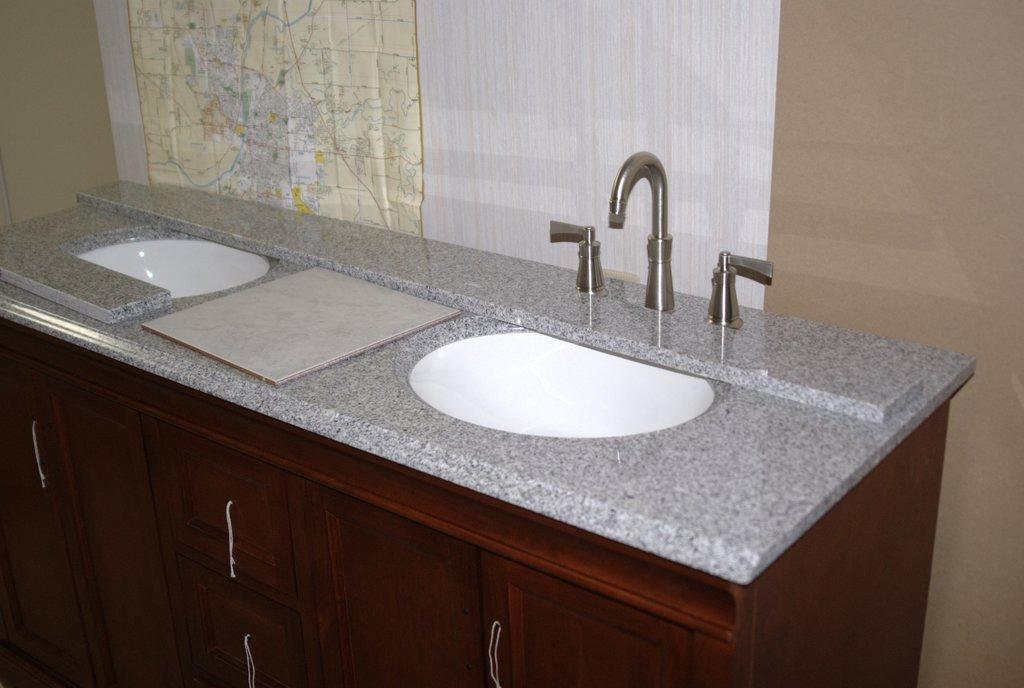How many sinks are visible in the image? There are two sinks in the image. What is located above the sinks? There is a tap in the image. What type of storage is available below the sinks? There are cupboards below the sinks. What can be seen on the wall in the background of the image? A map is attached to the wall. What type of plastic material is used to construct the hammer in the image? There is no hammer present in the image. What time of day is depicted in the image? The time of day cannot be determined from the image, as there are no clocks or other time-related objects present. 